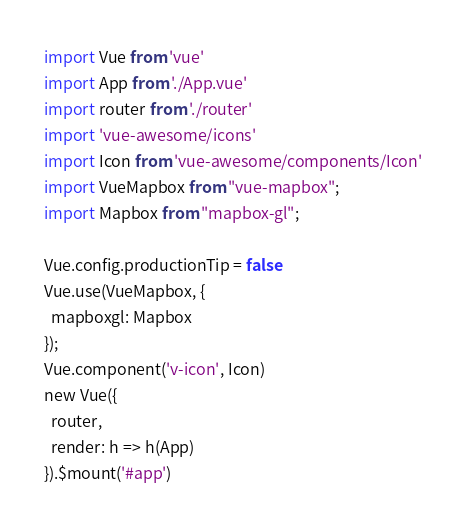<code> <loc_0><loc_0><loc_500><loc_500><_JavaScript_>import Vue from 'vue'
import App from './App.vue'
import router from './router'
import 'vue-awesome/icons'
import Icon from 'vue-awesome/components/Icon'
import VueMapbox from "vue-mapbox";
import Mapbox from "mapbox-gl";

Vue.config.productionTip = false
Vue.use(VueMapbox, {
  mapboxgl: Mapbox
});
Vue.component('v-icon', Icon)
new Vue({
  router,
  render: h => h(App)
}).$mount('#app')</code> 